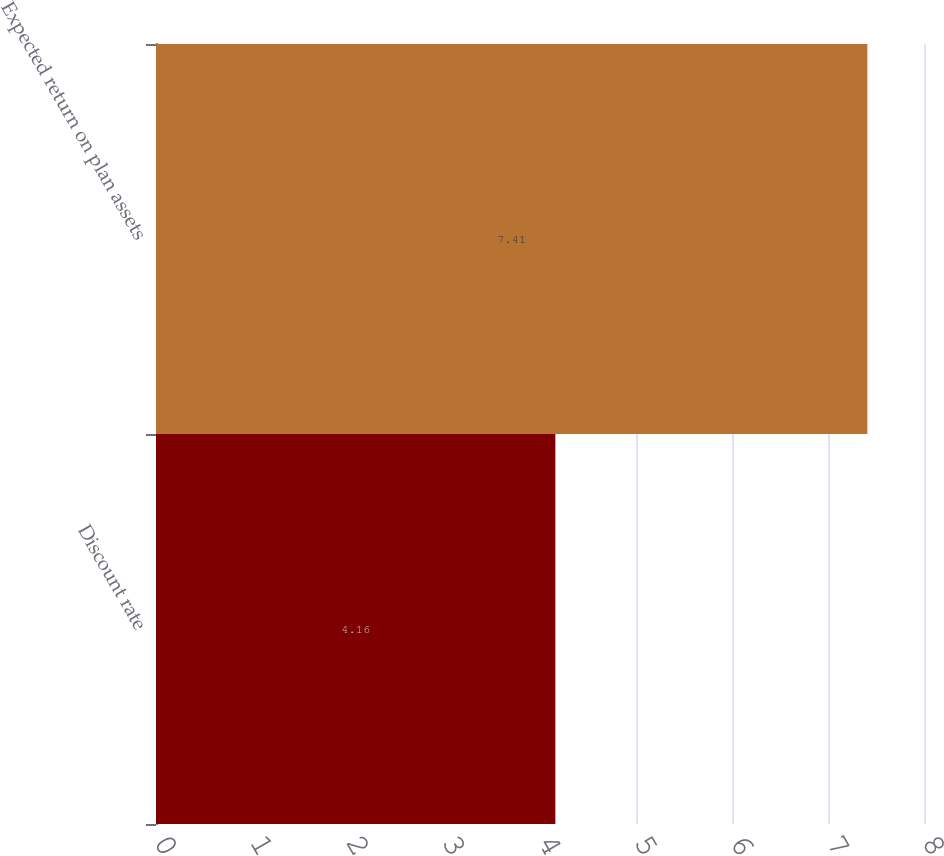Convert chart to OTSL. <chart><loc_0><loc_0><loc_500><loc_500><bar_chart><fcel>Discount rate<fcel>Expected return on plan assets<nl><fcel>4.16<fcel>7.41<nl></chart> 